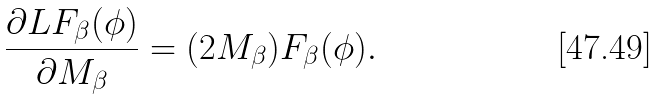Convert formula to latex. <formula><loc_0><loc_0><loc_500><loc_500>\frac { \partial L F _ { \beta } ( \phi ) } { \partial M _ { \beta } } = ( 2 M _ { \beta } ) F _ { \beta } ( \phi ) .</formula> 